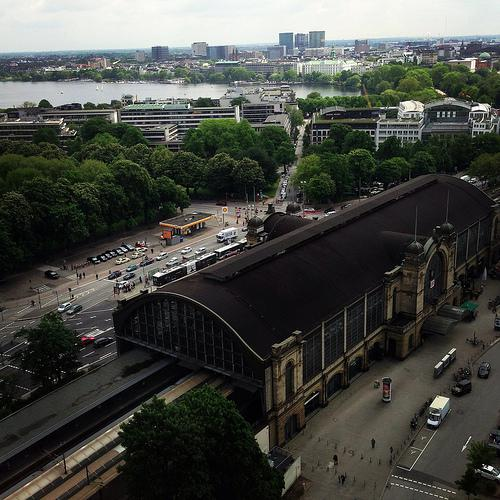Question: how many red cars do you see?
Choices:
A. Park.
B. Racing.
C. 1.
D. Showing.
Answer with the letter. Answer: C Question: what type of building is it?
Choices:
A. Subway station.
B. Terminal.
C. A skyscraper.
D. An office.
Answer with the letter. Answer: B Question: what color are the trees?
Choices:
A. Green.
B. Brown.
C. Gray.
D. White.
Answer with the letter. Answer: A 